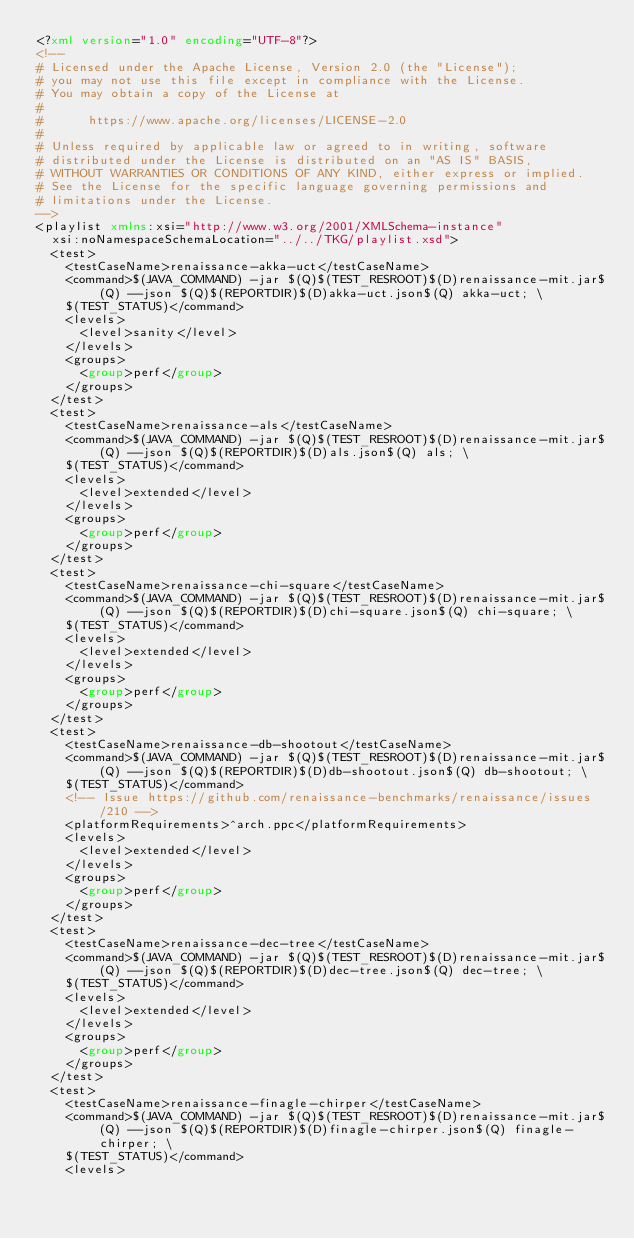Convert code to text. <code><loc_0><loc_0><loc_500><loc_500><_XML_><?xml version="1.0" encoding="UTF-8"?>
<!--
# Licensed under the Apache License, Version 2.0 (the "License");
# you may not use this file except in compliance with the License.
# You may obtain a copy of the License at
#
#      https://www.apache.org/licenses/LICENSE-2.0
#
# Unless required by applicable law or agreed to in writing, software
# distributed under the License is distributed on an "AS IS" BASIS,
# WITHOUT WARRANTIES OR CONDITIONS OF ANY KIND, either express or implied.
# See the License for the specific language governing permissions and
# limitations under the License.
-->
<playlist xmlns:xsi="http://www.w3.org/2001/XMLSchema-instance"
	xsi:noNamespaceSchemaLocation="../../TKG/playlist.xsd">
	<test>
		<testCaseName>renaissance-akka-uct</testCaseName>
		<command>$(JAVA_COMMAND) -jar $(Q)$(TEST_RESROOT)$(D)renaissance-mit.jar$(Q) --json $(Q)$(REPORTDIR)$(D)akka-uct.json$(Q) akka-uct; \
		$(TEST_STATUS)</command>
		<levels>
			<level>sanity</level>
		</levels>
		<groups>
			<group>perf</group>
		</groups>
	</test>
	<test>
		<testCaseName>renaissance-als</testCaseName>
		<command>$(JAVA_COMMAND) -jar $(Q)$(TEST_RESROOT)$(D)renaissance-mit.jar$(Q) --json $(Q)$(REPORTDIR)$(D)als.json$(Q) als; \
		$(TEST_STATUS)</command>
		<levels>
			<level>extended</level>
		</levels>
		<groups>
			<group>perf</group>
		</groups>
	</test>
	<test>
		<testCaseName>renaissance-chi-square</testCaseName>
		<command>$(JAVA_COMMAND) -jar $(Q)$(TEST_RESROOT)$(D)renaissance-mit.jar$(Q) --json $(Q)$(REPORTDIR)$(D)chi-square.json$(Q) chi-square; \
		$(TEST_STATUS)</command>
		<levels>
			<level>extended</level>
		</levels>
		<groups>
			<group>perf</group>
		</groups>
	</test>
	<test>
		<testCaseName>renaissance-db-shootout</testCaseName>
		<command>$(JAVA_COMMAND) -jar $(Q)$(TEST_RESROOT)$(D)renaissance-mit.jar$(Q) --json $(Q)$(REPORTDIR)$(D)db-shootout.json$(Q) db-shootout; \
		$(TEST_STATUS)</command>
		<!-- Issue https://github.com/renaissance-benchmarks/renaissance/issues/210 -->
		<platformRequirements>^arch.ppc</platformRequirements> 
		<levels> 
			<level>extended</level>
		</levels>
		<groups>
			<group>perf</group>
		</groups>
	</test>
	<test>
		<testCaseName>renaissance-dec-tree</testCaseName>
		<command>$(JAVA_COMMAND) -jar $(Q)$(TEST_RESROOT)$(D)renaissance-mit.jar$(Q) --json $(Q)$(REPORTDIR)$(D)dec-tree.json$(Q) dec-tree; \
		$(TEST_STATUS)</command>
		<levels>
			<level>extended</level>
		</levels>
		<groups>
			<group>perf</group>
		</groups>
	</test>
	<test>
		<testCaseName>renaissance-finagle-chirper</testCaseName>
		<command>$(JAVA_COMMAND) -jar $(Q)$(TEST_RESROOT)$(D)renaissance-mit.jar$(Q) --json $(Q)$(REPORTDIR)$(D)finagle-chirper.json$(Q) finagle-chirper; \
		$(TEST_STATUS)</command>			
		<levels></code> 